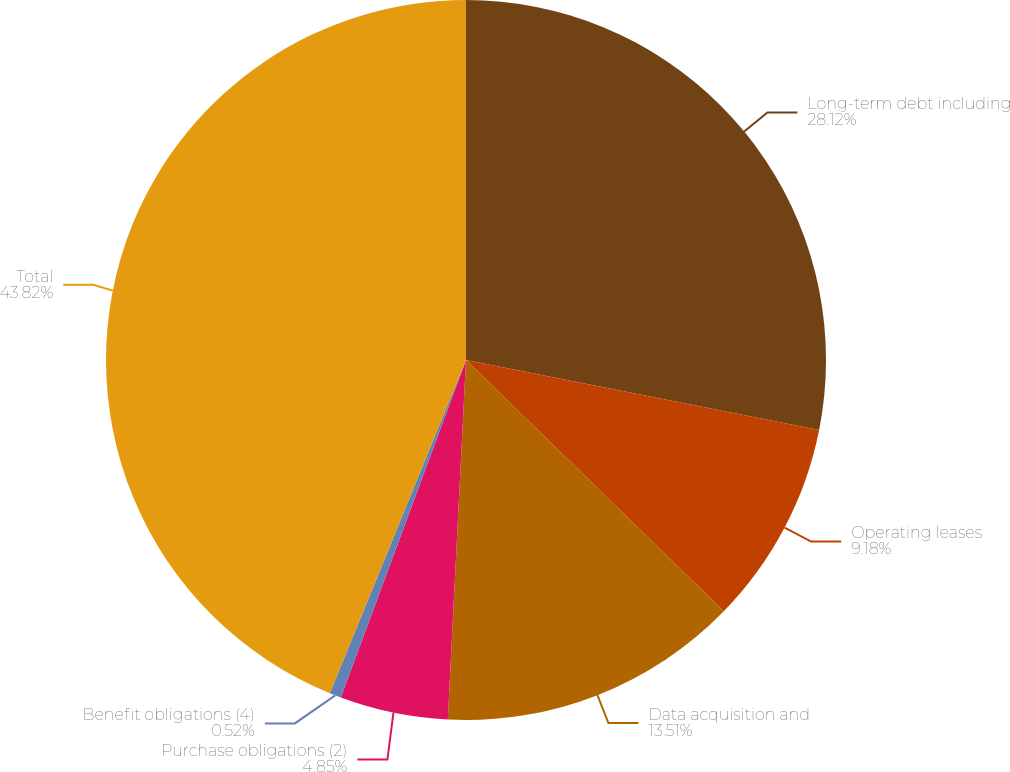<chart> <loc_0><loc_0><loc_500><loc_500><pie_chart><fcel>Long-term debt including<fcel>Operating leases<fcel>Data acquisition and<fcel>Purchase obligations (2)<fcel>Benefit obligations (4)<fcel>Total<nl><fcel>28.12%<fcel>9.18%<fcel>13.51%<fcel>4.85%<fcel>0.52%<fcel>43.83%<nl></chart> 